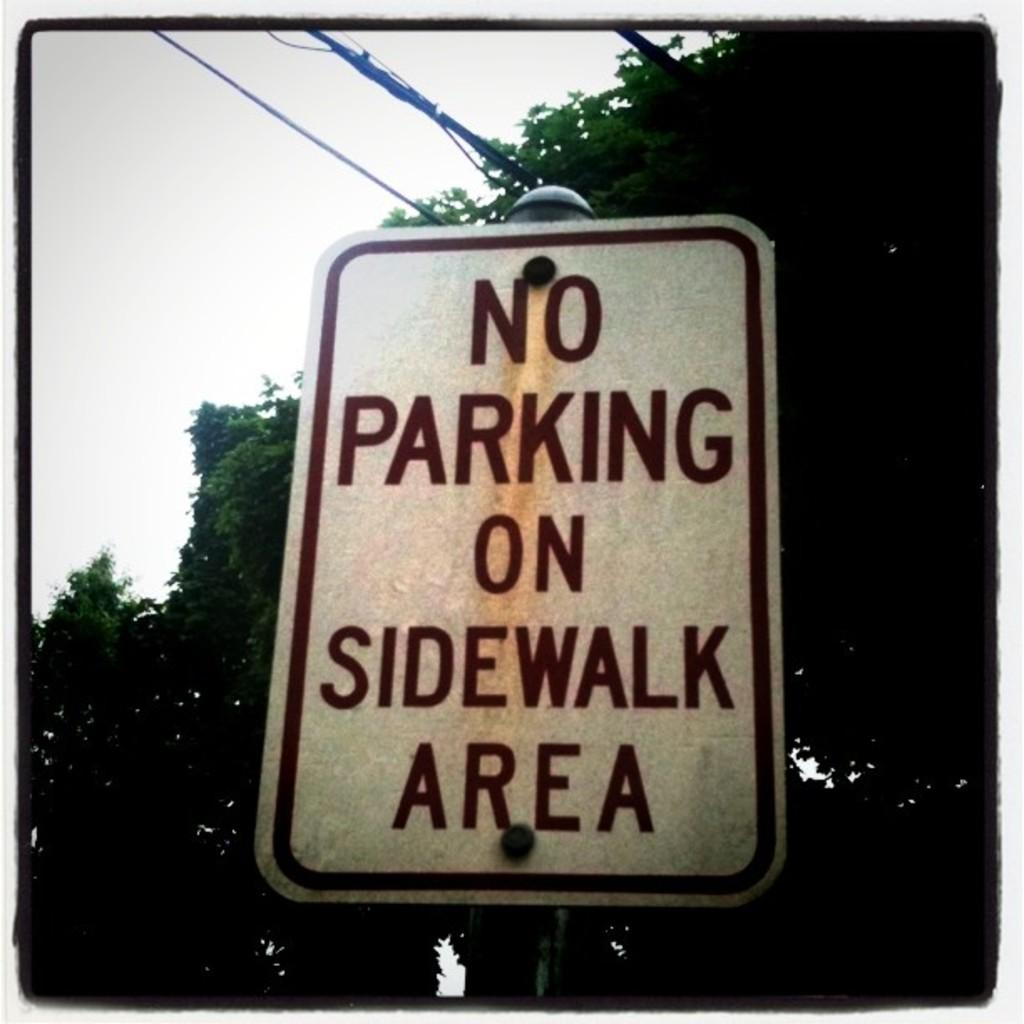<image>
Render a clear and concise summary of the photo. A white sign that says No Parking On Sidewalk Area has power lines running above it. 